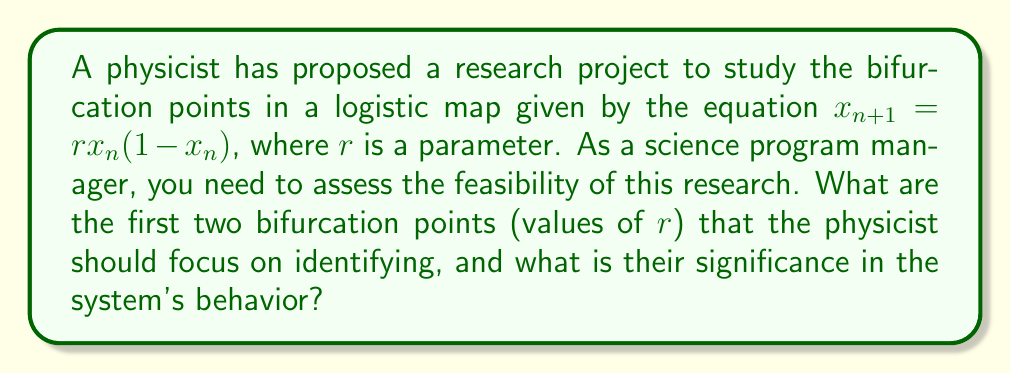What is the answer to this math problem? To determine the bifurcation points in the logistic map, we need to follow these steps:

1) The logistic map is given by: $x_{n+1} = rx_n(1-x_n)$

2) For $0 < r < 1$, the system has only one fixed point at $x = 0$.

3) The first bifurcation occurs at $r = 1$. For $1 < r < 3$, the system has a non-zero fixed point at $x = 1 - \frac{1}{r}$.

4) To find the second bifurcation point, we need to solve for when the fixed point becomes unstable. This occurs when the derivative of the map at the fixed point equals -1:

   $$\left.\frac{d}{dx}(rx(1-x))\right|_{x=1-\frac{1}{r}} = -1$$

5) Solving this equation:
   
   $$r(1-2(1-\frac{1}{r})) = -1$$
   $$r(2\frac{1}{r}-1) = -1$$
   $$2-r = -1$$
   $$r = 3$$

6) Therefore, the second bifurcation occurs at $r = 3$. For $3 < r < 1+\sqrt{6}$, the system oscillates between two values.

These bifurcation points are significant because:

- At $r = 1$, the system transitions from having no non-zero fixed point to having one.
- At $r = 3$, the system transitions from having one stable fixed point to oscillating between two values, marking the beginning of the period-doubling route to chaos.

Understanding these points is crucial for studying the system's long-term behavior and the transition to chaos.
Answer: $r = 1$ and $r = 3$ 